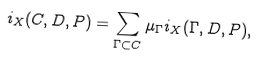Convert formula to latex. <formula><loc_0><loc_0><loc_500><loc_500>i _ { X } ( C , D , P ) = \sum _ { \Gamma \subset C } \mu _ { \Gamma } i _ { X } ( \Gamma , D , P ) ,</formula> 